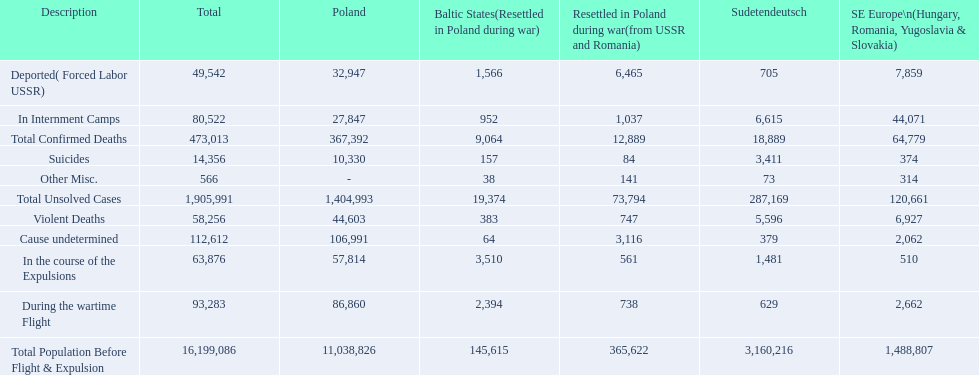What are the numbers of violent deaths across the area? 44,603, 383, 747, 5,596, 6,927. What is the total number of violent deaths of the area? 58,256. 